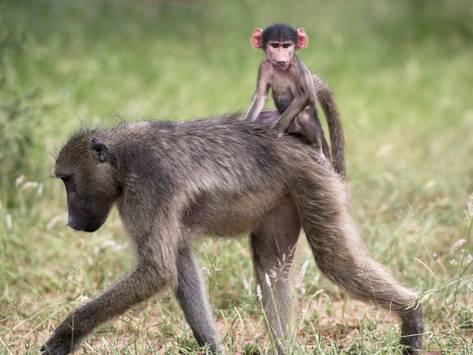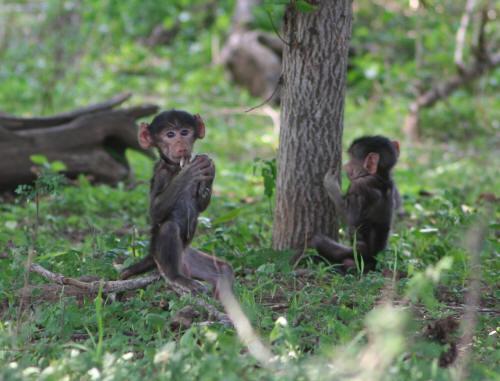The first image is the image on the left, the second image is the image on the right. For the images shown, is this caption "A baby baboon is clinging to an adult baboon walking on all fours in one image, and each image contains at least one baby baboon." true? Answer yes or no. Yes. The first image is the image on the left, the second image is the image on the right. For the images displayed, is the sentence "The right image contains at least two monkeys." factually correct? Answer yes or no. Yes. 